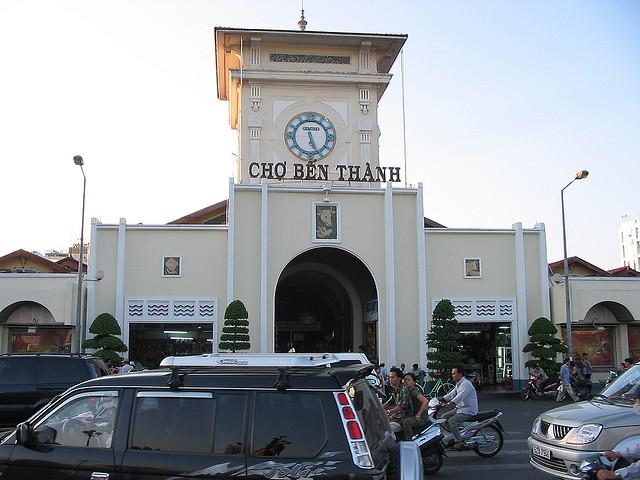Judging from the signage beneath the clock where is this structure located? Please explain your reasoning. asia. The sign is in vietnamese. 